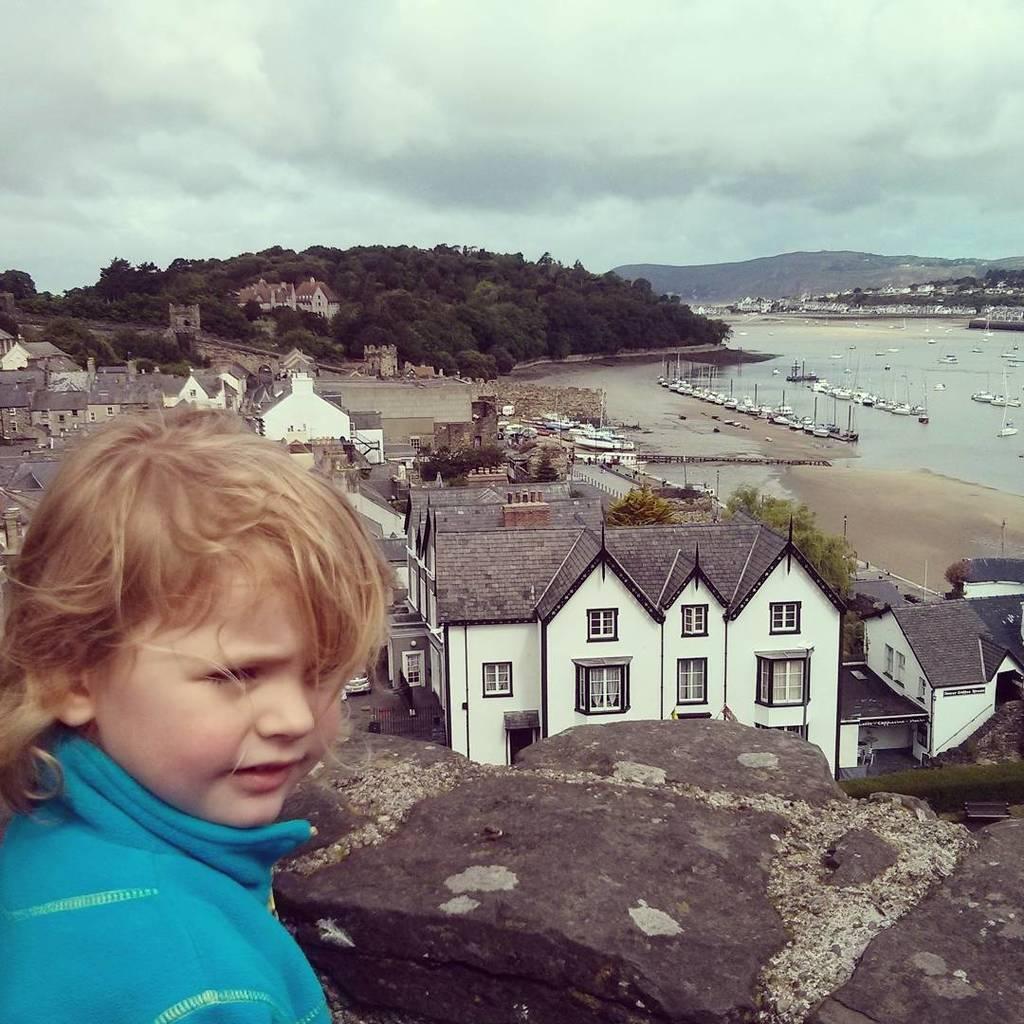Please provide a concise description of this image. In this image in the foreground there is one girl who is standing, and on the right side there are some houses, buildings, vehicles, and some trees and mountains and also there is one beach. In the beach we could see some boats, and in the background there are some trees and mountains. 